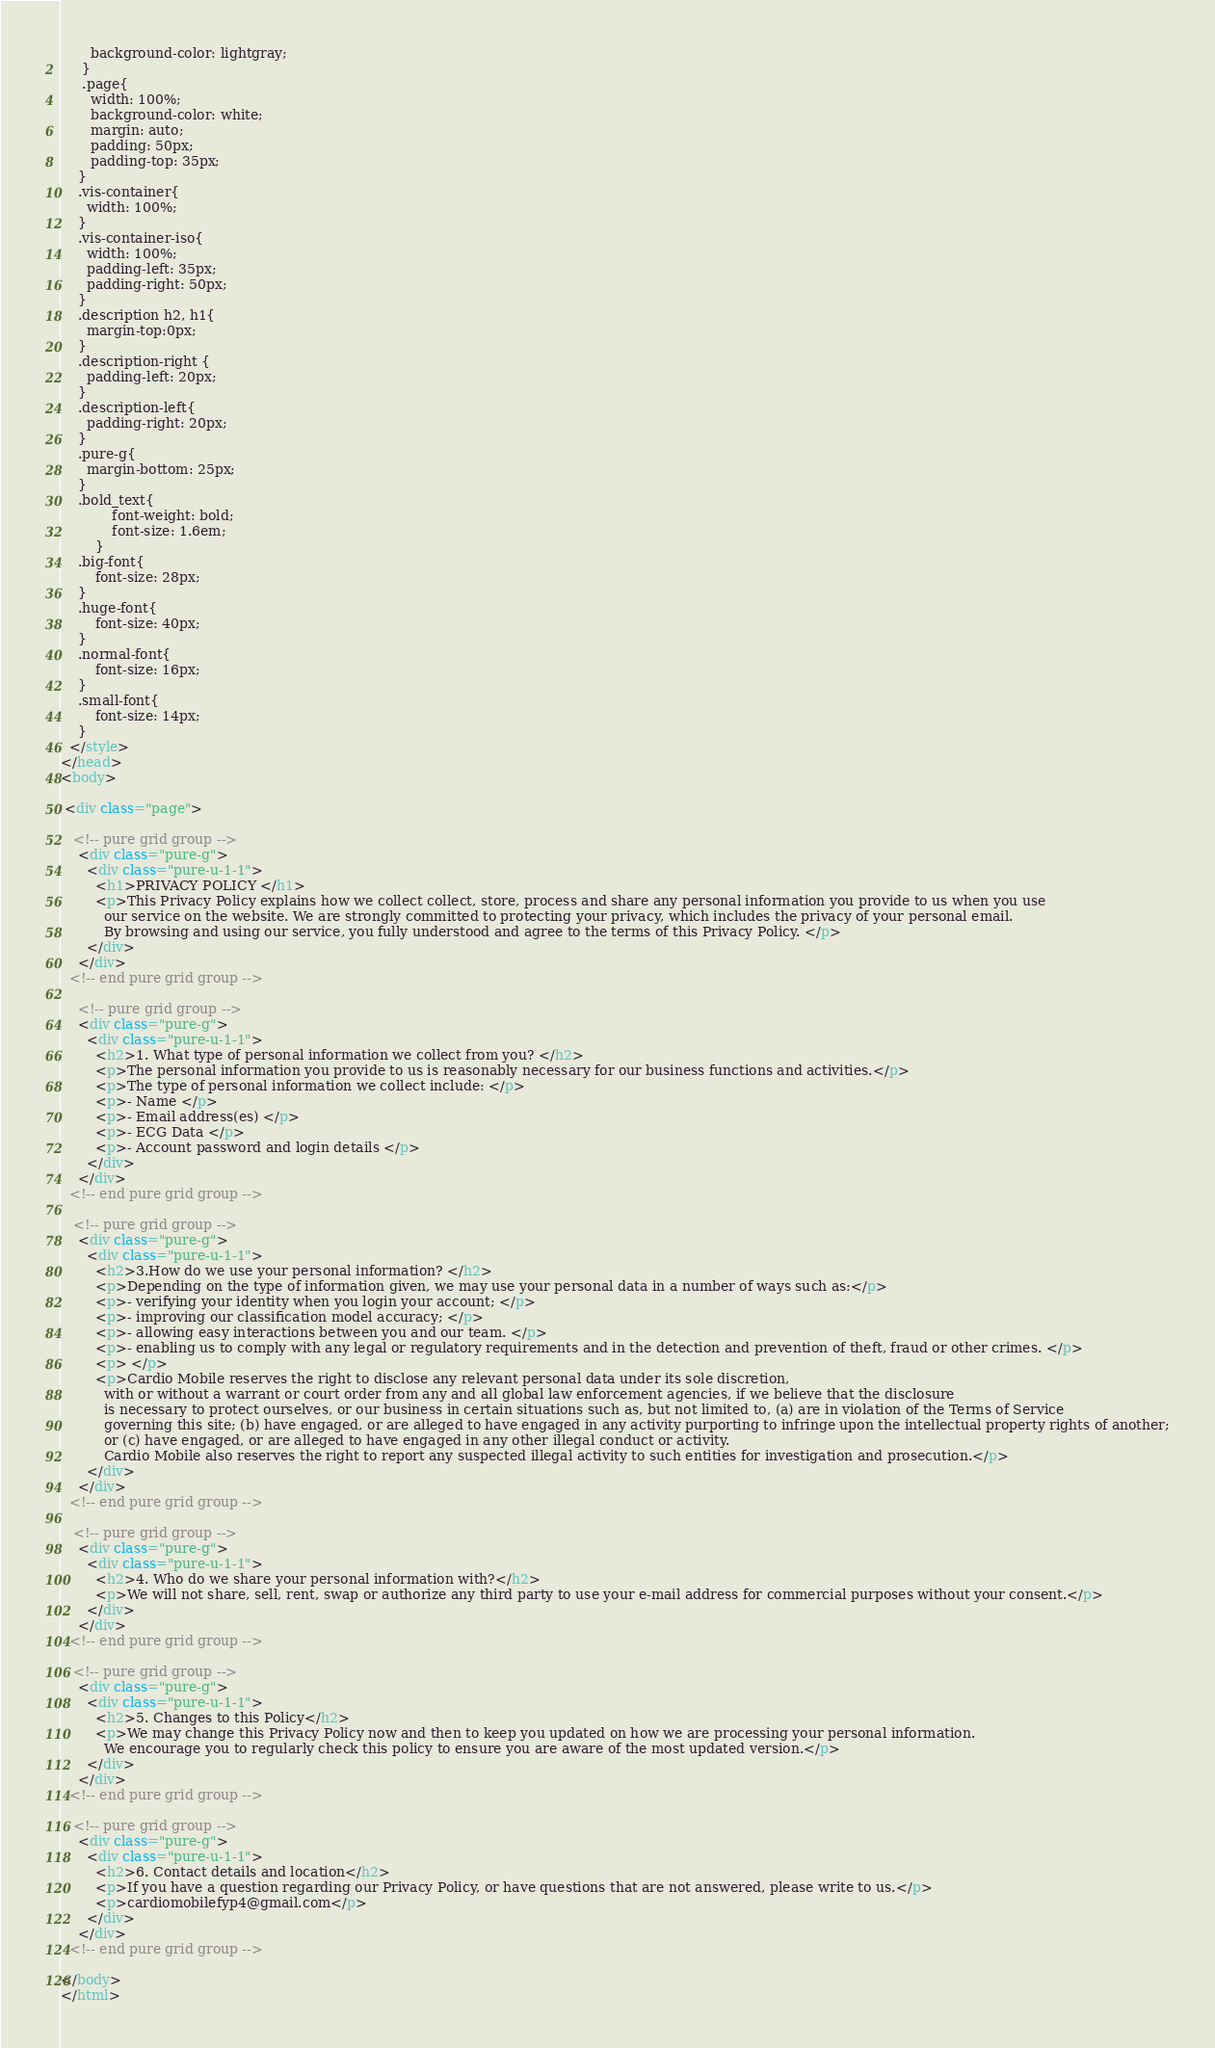Convert code to text. <code><loc_0><loc_0><loc_500><loc_500><_HTML_>       background-color: lightgray;
     }
     .page{
       width: 100%;    
       background-color: white;   
       margin: auto;
       padding: 50px;
       padding-top: 35px;
    }
    .vis-container{
      width: 100%;
    }
    .vis-container-iso{
      width: 100%;
      padding-left: 35px;
      padding-right: 50px;
    }
    .description h2, h1{
      margin-top:0px;
    }
    .description-right {
      padding-left: 20px;
    }
    .description-left{
      padding-right: 20px;
    }
    .pure-g{
      margin-bottom: 25px;
    }
    .bold_text{
            font-weight: bold;
            font-size: 1.6em;
        }
    .big-font{
        font-size: 28px;
    }
    .huge-font{
        font-size: 40px;
    }
    .normal-font{
        font-size: 16px;
    }
    .small-font{
        font-size: 14px;
    }
  </style>
</head>
<body>

 <div class="page">

   <!-- pure grid group -->
    <div class="pure-g">
      <div class="pure-u-1-1">
        <h1>PRIVACY POLICY </h1>
        <p>This Privacy Policy explains how we collect collect, store, process and share any personal information you provide to us when you use
          our service on the website. We are strongly committed to protecting your privacy, which includes the privacy of your personal email.
          By browsing and using our service, you fully understood and agree to the terms of this Privacy Policy. </p>
      </div>
    </div>
  <!-- end pure grid group -->
   
    <!-- pure grid group -->
    <div class="pure-g">
      <div class="pure-u-1-1">
        <h2>1. What type of personal information we collect from you? </h2>
        <p>The personal information you provide to us is reasonably necessary for our business functions and activities.</p>
        <p>The type of personal information we collect include: </p>
        <p>- Name </p>
        <p>- Email address(es) </p>
        <p>- ECG Data </p>
        <p>- Account password and login details </p>
      </div>
    </div>
  <!-- end pure grid group -->
   
   <!-- pure grid group -->
    <div class="pure-g">
      <div class="pure-u-1-1">
        <h2>3.How do we use your personal information? </h2>
        <p>Depending on the type of information given, we may use your personal data in a number of ways such as:</p>
        <p>- verifying your identity when you login your account; </p>
        <p>- improving our classification model accuracy; </p>
        <p>- allowing easy interactions between you and our team. </p>
        <p>- enabling us to comply with any legal or regulatory requirements and in the detection and prevention of theft, fraud or other crimes. </p>
        <p> </p>
        <p>Cardio Mobile reserves the right to disclose any relevant personal data under its sole discretion, 
          with or without a warrant or court order from any and all global law enforcement agencies, if we believe that the disclosure 
          is necessary to protect ourselves, or our business in certain situations such as, but not limited to, (a) are in violation of the Terms of Service 
          governing this site; (b) have engaged, or are alleged to have engaged in any activity purporting to infringe upon the intellectual property rights of another;
          or (c) have engaged, or are alleged to have engaged in any other illegal conduct or activity. 
          Cardio Mobile also reserves the right to report any suspected illegal activity to such entities for investigation and prosecution.</p>
      </div>
    </div>
  <!-- end pure grid group -->
   
   <!-- pure grid group -->
    <div class="pure-g">
      <div class="pure-u-1-1">
        <h2>4. Who do we share your personal information with?</h2>
        <p>We will not share, sell, rent, swap or authorize any third party to use your e-mail address for commercial purposes without your consent.</p>
      </div>
    </div>
  <!-- end pure grid group -->
   
   <!-- pure grid group -->
    <div class="pure-g">
      <div class="pure-u-1-1">
        <h2>5. Changes to this Policy</h2>
        <p>We may change this Privacy Policy now and then to keep you updated on how we are processing your personal information. 
          We encourage you to regularly check this policy to ensure you are aware of the most updated version.</p>
      </div>
    </div>
  <!-- end pure grid group -->
   
   <!-- pure grid group -->
    <div class="pure-g">
      <div class="pure-u-1-1">
        <h2>6. Contact details and location</h2>
        <p>If you have a question regarding our Privacy Policy, or have questions that are not answered, please write to us.</p>
        <p>cardiomobilefyp4@gmail.com</p>
      </div>
    </div>
  <!-- end pure grid group -->
 
</body>
</html>
</code> 